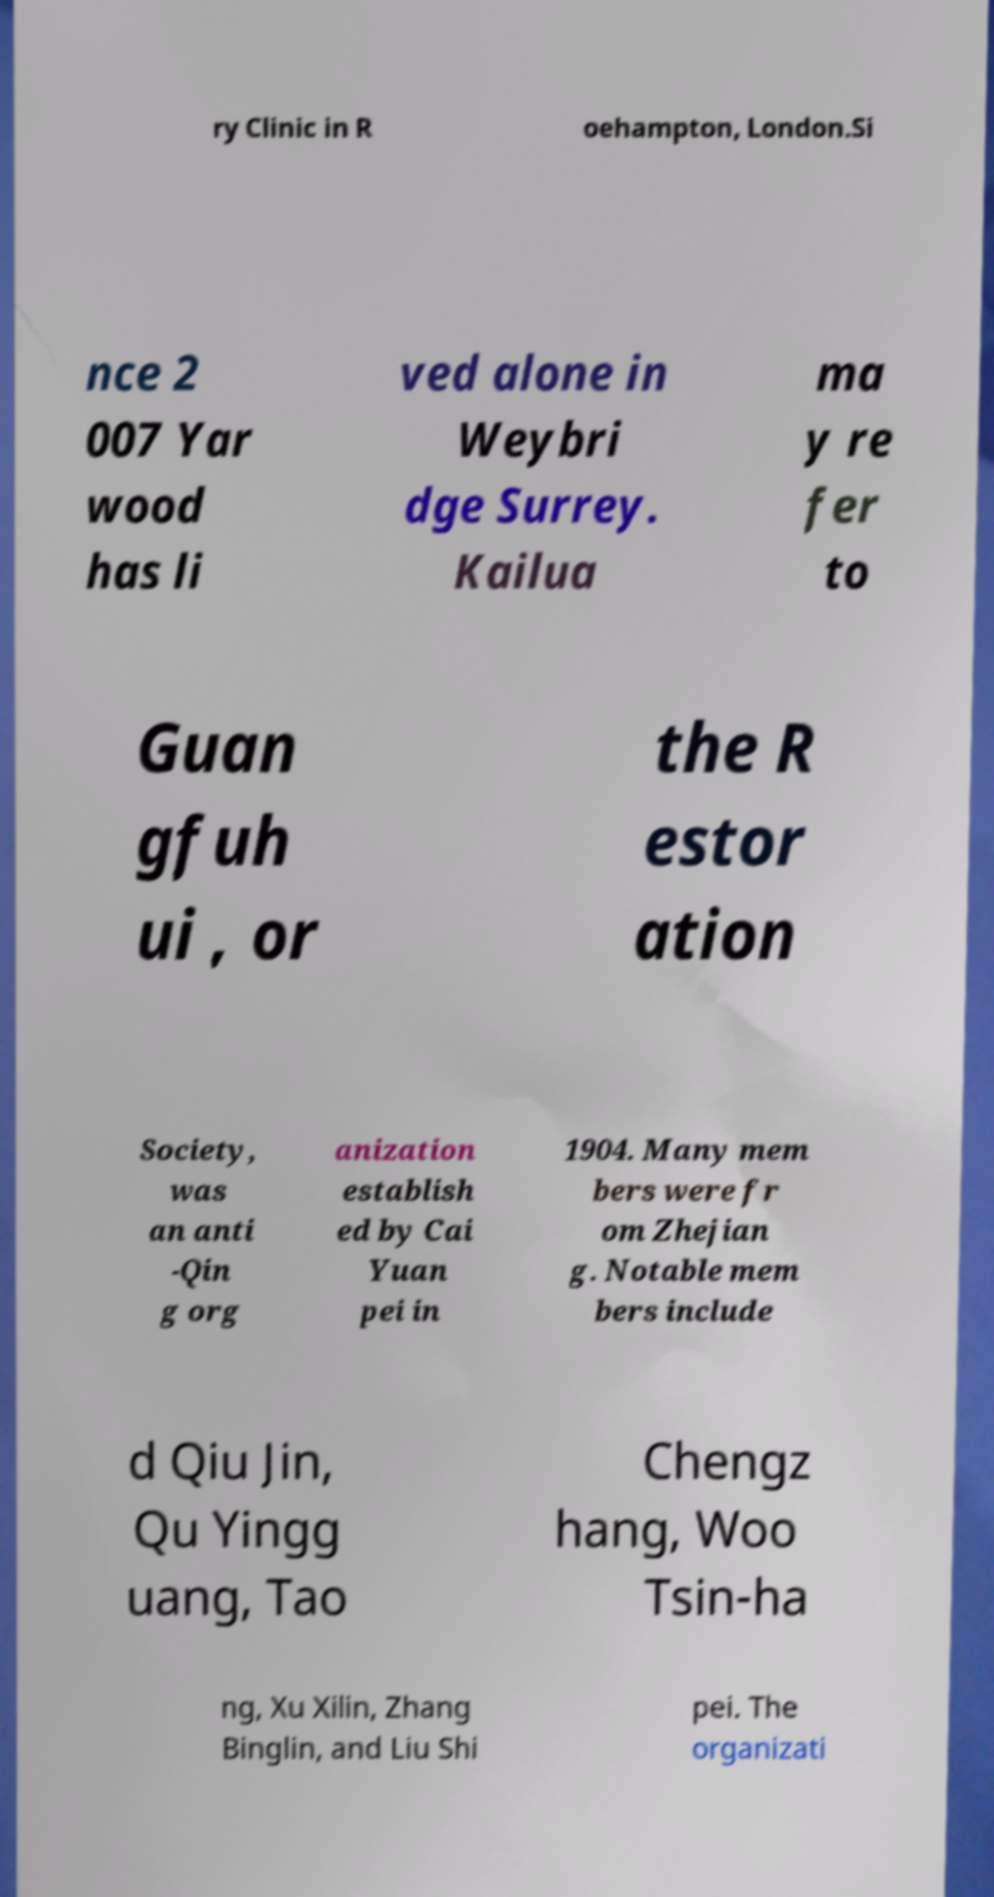Could you assist in decoding the text presented in this image and type it out clearly? ry Clinic in R oehampton, London.Si nce 2 007 Yar wood has li ved alone in Weybri dge Surrey. Kailua ma y re fer to Guan gfuh ui , or the R estor ation Society, was an anti -Qin g org anization establish ed by Cai Yuan pei in 1904. Many mem bers were fr om Zhejian g. Notable mem bers include d Qiu Jin, Qu Yingg uang, Tao Chengz hang, Woo Tsin-ha ng, Xu Xilin, Zhang Binglin, and Liu Shi pei. The organizati 